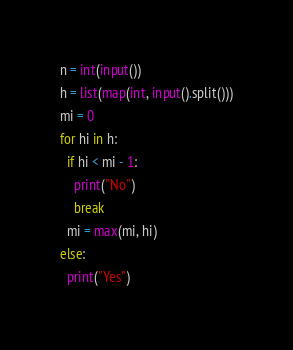Convert code to text. <code><loc_0><loc_0><loc_500><loc_500><_Python_>n = int(input())
h = list(map(int, input().split()))
mi = 0
for hi in h:
  if hi < mi - 1:
    print("No")
    break
  mi = max(mi, hi)
else:
  print("Yes")</code> 